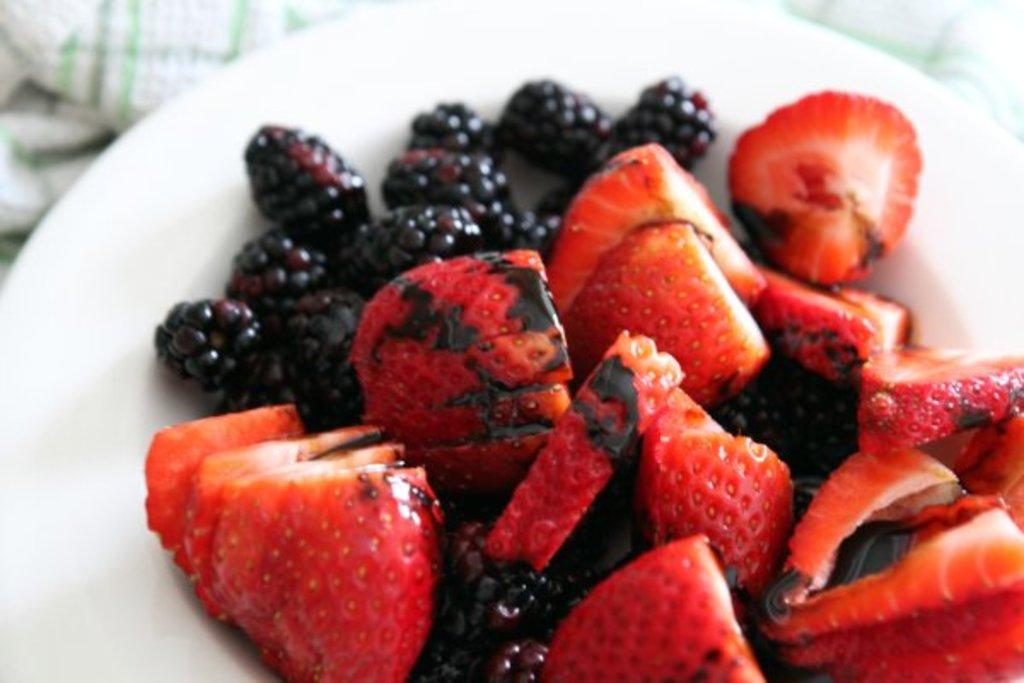What type of fruit can be seen in the image? There are strawberry pieces and blueberries in the image. How are the strawberries and blueberries arranged in the image? The strawberries and blueberries are on a plate in the image. What additional item is visible in the image? There is a towel visible in the image. What type of bean is present on the lip of the person in the image? There is no person or bean present in the image; it only features strawberries, blueberries, a plate, and a towel. 